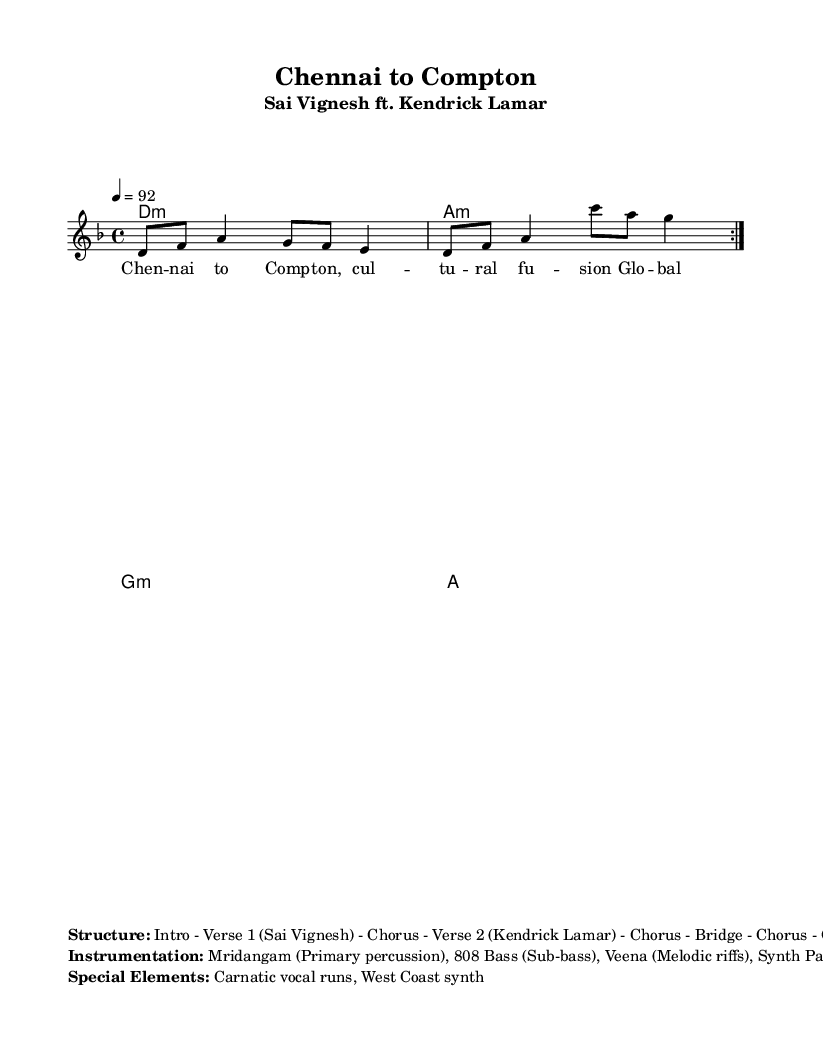What is the key signature of this music? The key signature is D minor, which indicates that there is one flat (B flat) in the scale. This can be identified in the global section of the sheet music where the key is specified.
Answer: D minor What is the time signature of this music? The time signature is 4/4, which means there are four beats in each measure. This is clearly indicated in the global section right after the key signature.
Answer: 4/4 What is the tempo marking for this piece? The tempo marking is 92, meaning the piece should be played at 92 beats per minute. This is specified in the global section of the music sheet.
Answer: 92 What is the primary percussion instrument used in this rap? The primary percussion instrument specified in the instrumentation section is the Mridangam, which is traditional to South Indian music. This detail is directly mentioned in the markup section.
Answer: Mridangam How many verses are there in the structure of this rap? The structure includes two verses, one by Sai Vignesh and the other by Kendrick Lamar, as indicated in the "Structure" part of the markup.
Answer: 2 What cultural element is highlighted in the lyrics of this rap? The lyrics highlight "cultural fusion," showcasing the blend of Western and South Indian influences in the music. This is explicitly mentioned in the line from the lyrics.
Answer: Cultural fusion What special musical element is incorporated into this rap? The special musical element incorporated in this rap is "Carnatic vocal runs," which refers to intricate vocal techniques from South Indian classical music. This is noted in the special elements section.
Answer: Carnatic vocal runs 